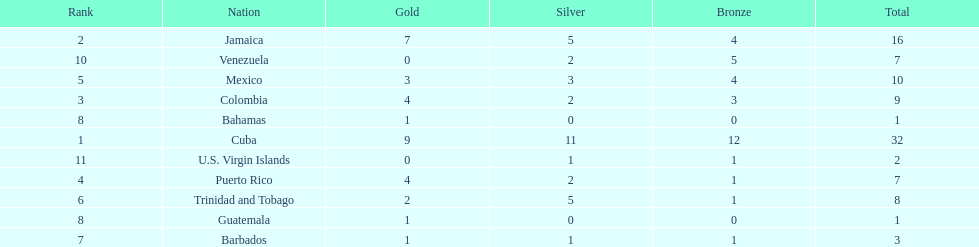What teams had four gold medals? Colombia, Puerto Rico. Of these two, which team only had one bronze medal? Puerto Rico. 